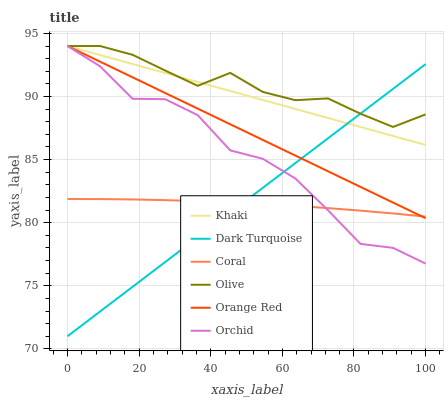Does Dark Turquoise have the minimum area under the curve?
Answer yes or no. No. Does Dark Turquoise have the maximum area under the curve?
Answer yes or no. No. Is Dark Turquoise the smoothest?
Answer yes or no. No. Is Dark Turquoise the roughest?
Answer yes or no. No. Does Coral have the lowest value?
Answer yes or no. No. Does Dark Turquoise have the highest value?
Answer yes or no. No. Is Coral less than Khaki?
Answer yes or no. Yes. Is Olive greater than Coral?
Answer yes or no. Yes. Does Coral intersect Khaki?
Answer yes or no. No. 